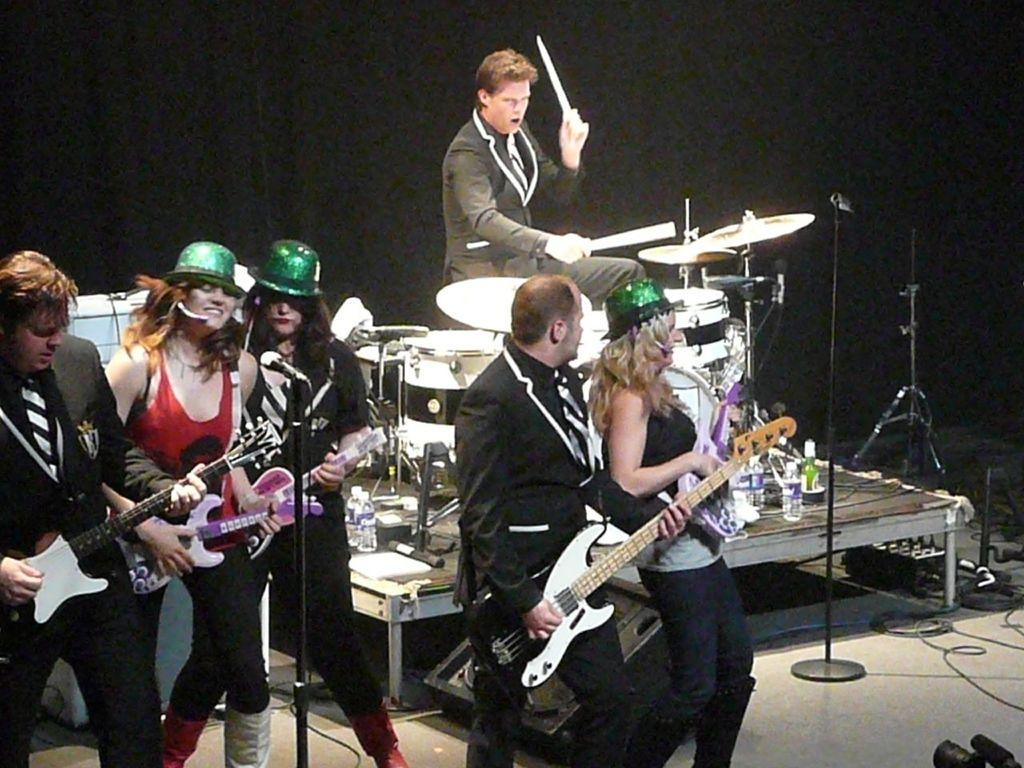How many people are in the image? There are people in the image, but the exact number is not specified. What are the people doing in the image? The people are standing and holding guitars. Can you describe the man in the image? Yes, there is a man in the image, and he is playing a drum set. What type of hill can be seen in the background of the image? There is no hill present in the image; it features people holding guitars and a man playing a drum set. What kind of agreement was reached by the people in the image? There is no indication in the image that the people have reached any agreement or are engaged in any discussions. 